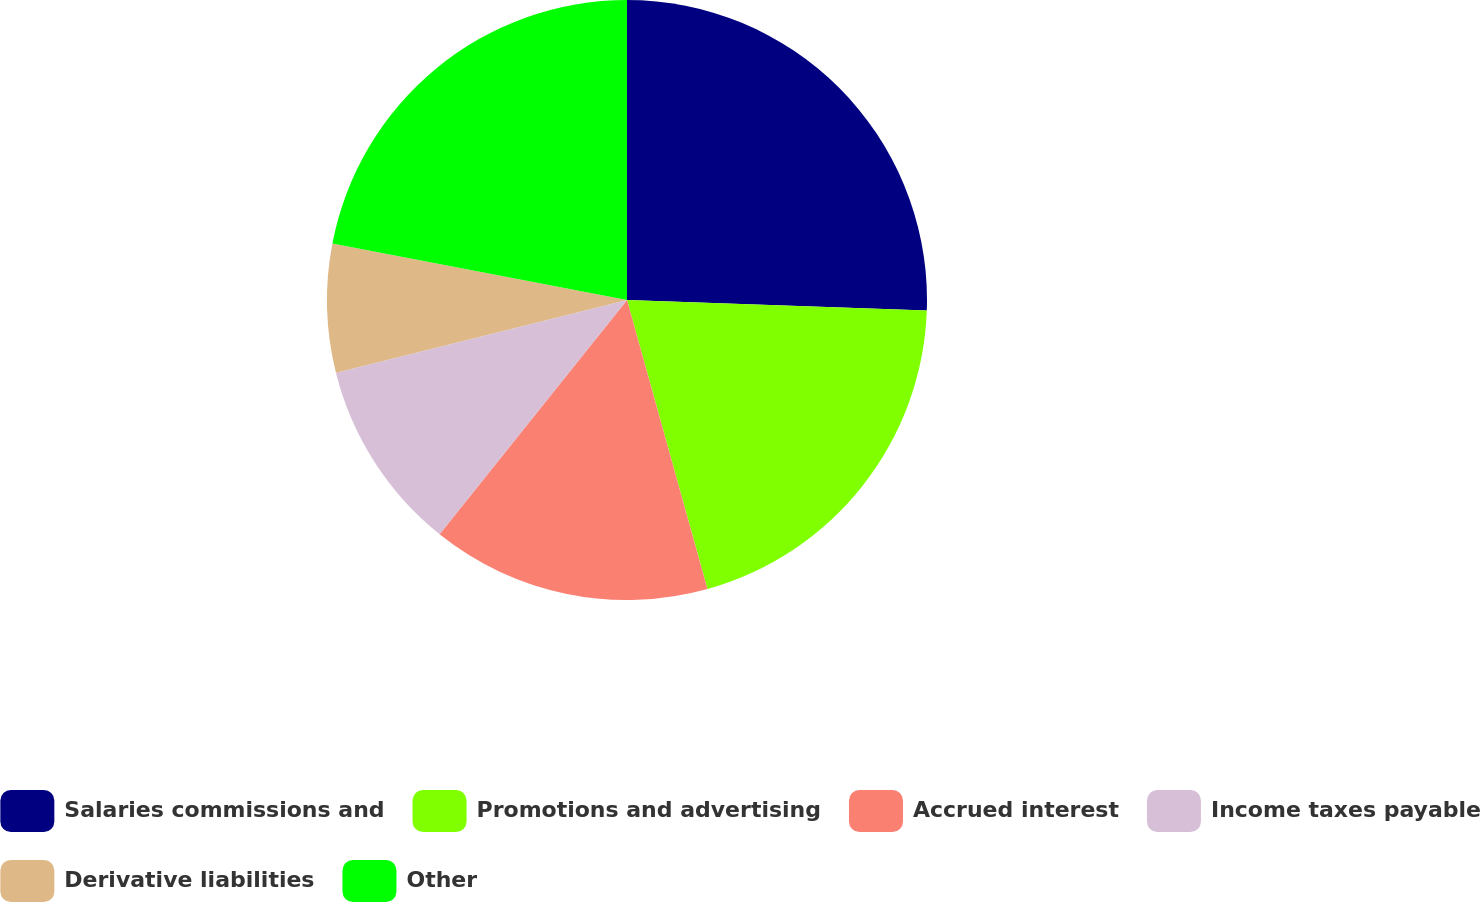<chart> <loc_0><loc_0><loc_500><loc_500><pie_chart><fcel>Salaries commissions and<fcel>Promotions and advertising<fcel>Accrued interest<fcel>Income taxes payable<fcel>Derivative liabilities<fcel>Other<nl><fcel>25.56%<fcel>20.12%<fcel>15.06%<fcel>10.36%<fcel>6.92%<fcel>21.98%<nl></chart> 